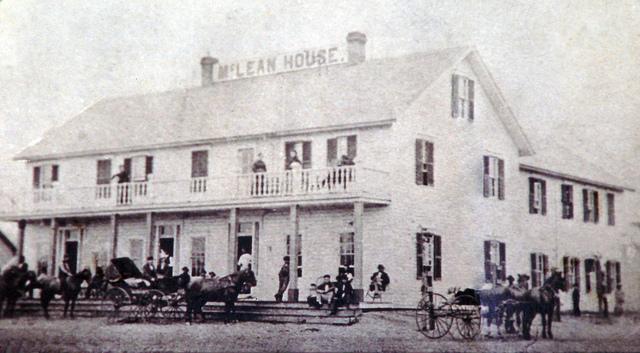What is written at the top left?
Be succinct. Mclean house. How many horses are there in the photo?
Give a very brief answer. 4. What was the popular mode of transportation during the time this photo was taken?
Give a very brief answer. Horse and buggy. Was this photo taken in the last 20 years?
Give a very brief answer. No. 